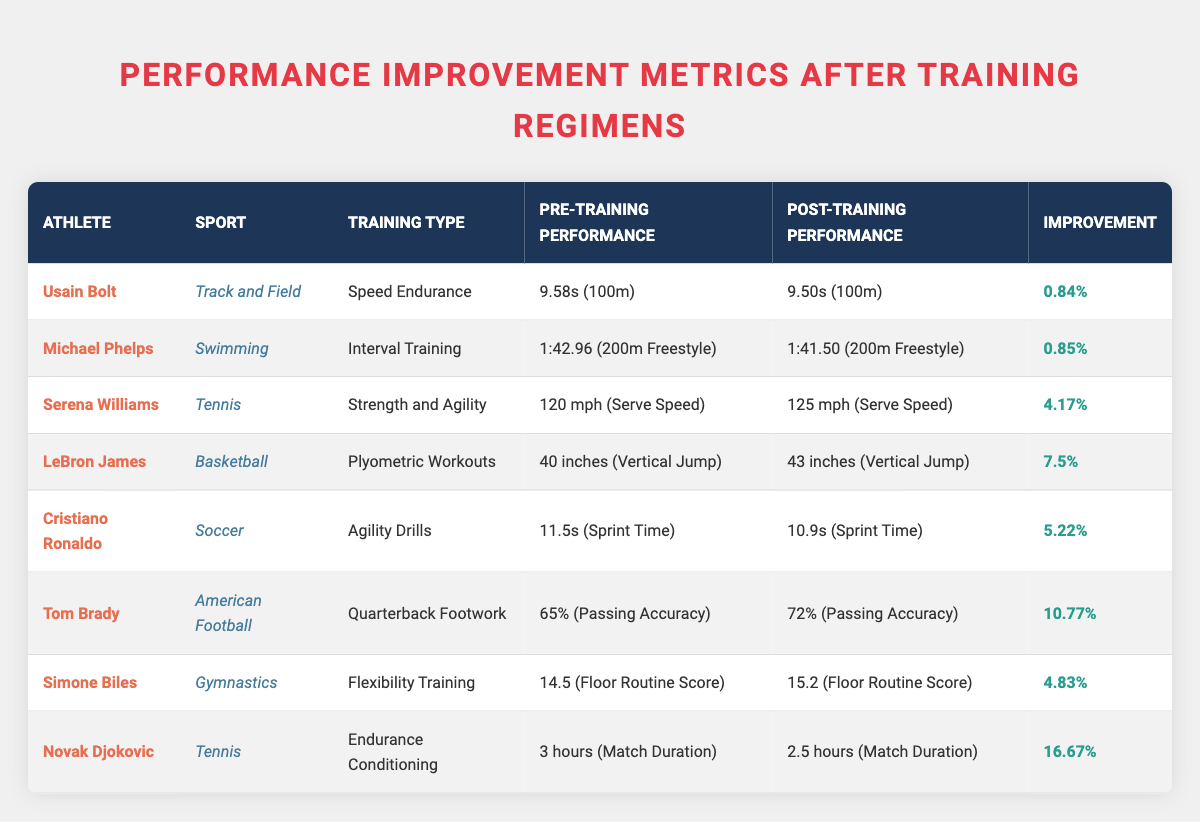What is the improvement percentage for Usain Bolt? The table indicates that Usain Bolt had an improvement percentage of **0.84%** after his training regimen.
Answer: 0.84% Which athlete showed the greatest improvement percentage after training? By examining the improvement percentages for all athletes, Novak Djokovic had the highest improvement at **16.67%**.
Answer: 16.67% Did any athlete's performance improve by more than 10%? Yes, Tom Brady and Novak Djokovic both had improvements greater than 10%, with Brady at **10.77%** and Djokovic at **16.67%**.
Answer: Yes What was Michael Phelps' pre-training time for the 200m freestyle? According to the table, Michael Phelps' pre-training time for the 200m freestyle was **1:42.96**.
Answer: 1:42.96 What was the average improvement percentage across all athletes? The improvement percentages are **0.84%, 0.85%, 4.17%, 7.5%, 5.22%, 10.77%, 4.83%, 16.67%**. The sum is **50.05%** and there are **8 athletes**, so the average is **50.05% / 8 = 6.26%**.
Answer: 6.26% What is the percentage improvement of LeBron James compared to that of Serena Williams? LeBron James improved by **7.5%** and Serena Williams improved by **4.17%**. The difference is **7.5% - 4.17% = 3.33%**.
Answer: 3.33% Was there any athlete who decreased their performance time? Yes, Novak Djokovic decreased his match duration from **3 hours** to **2.5 hours**, indicating an improvement.
Answer: Yes How much faster did Cristiano Ronaldo run his sprint after training? Cristiano Ronaldo's pre-training sprint time was **11.5s**, and his post-training sprint time was **10.9s**. The difference is **11.5s - 10.9s = 0.6s**.
Answer: 0.6s Which sport had the second-best improvement percentage and what was it? The second-best improvement percentage was by Tom Brady in American Football with an improvement of **10.77%**.
Answer: 10.77% What is the difference in serve speed for Serena Williams after her training? Serena Williams' pre-training serve speed was **120 mph** and her post-training serve speed was **125 mph**, resulting in a difference of **125 mph - 120 mph = 5 mph**.
Answer: 5 mph True or False: All athletes improved their performance metrics. True, all athletes listed in the table showed improvements in their respective performance metrics.
Answer: True 